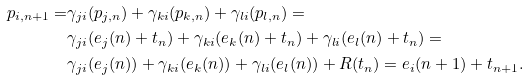<formula> <loc_0><loc_0><loc_500><loc_500>p _ { i , n + 1 } = & \gamma _ { j i } ( p _ { j , n } ) + \gamma _ { k i } ( p _ { k , n } ) + \gamma _ { l i } ( p _ { l , n } ) = \\ & \gamma _ { j i } ( e _ { j } ( n ) + t _ { n } ) + \gamma _ { k i } ( e _ { k } ( n ) + t _ { n } ) + \gamma _ { l i } ( e _ { l } ( n ) + t _ { n } ) = \\ & \gamma _ { j i } ( e _ { j } ( n ) ) + \gamma _ { k i } ( e _ { k } ( n ) ) + \gamma _ { l i } ( e _ { l } ( n ) ) + R ( t _ { n } ) = e _ { i } ( n + 1 ) + t _ { n + 1 } .</formula> 